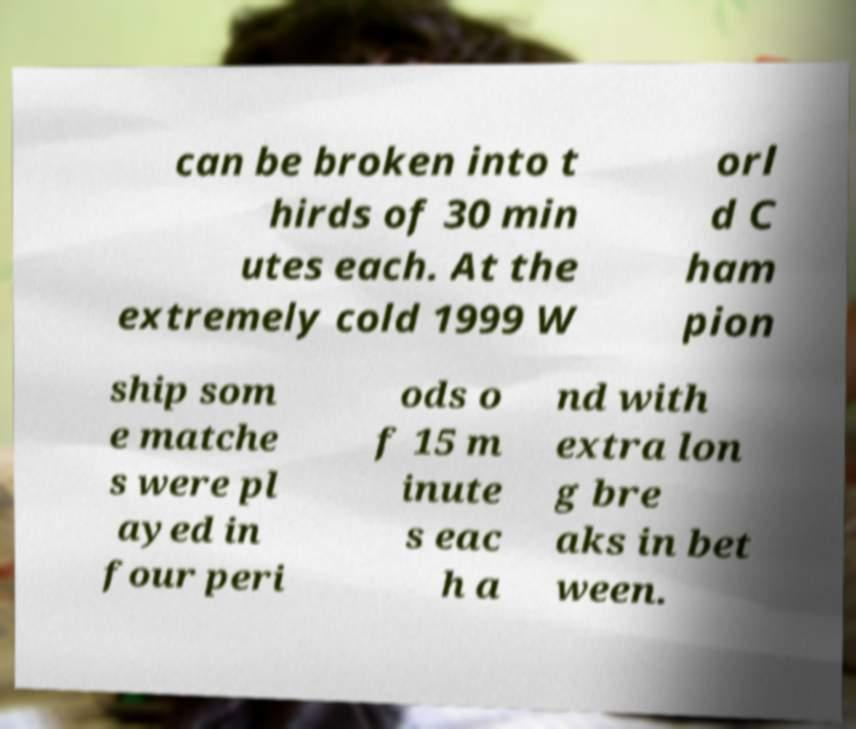Please read and relay the text visible in this image. What does it say? can be broken into t hirds of 30 min utes each. At the extremely cold 1999 W orl d C ham pion ship som e matche s were pl ayed in four peri ods o f 15 m inute s eac h a nd with extra lon g bre aks in bet ween. 